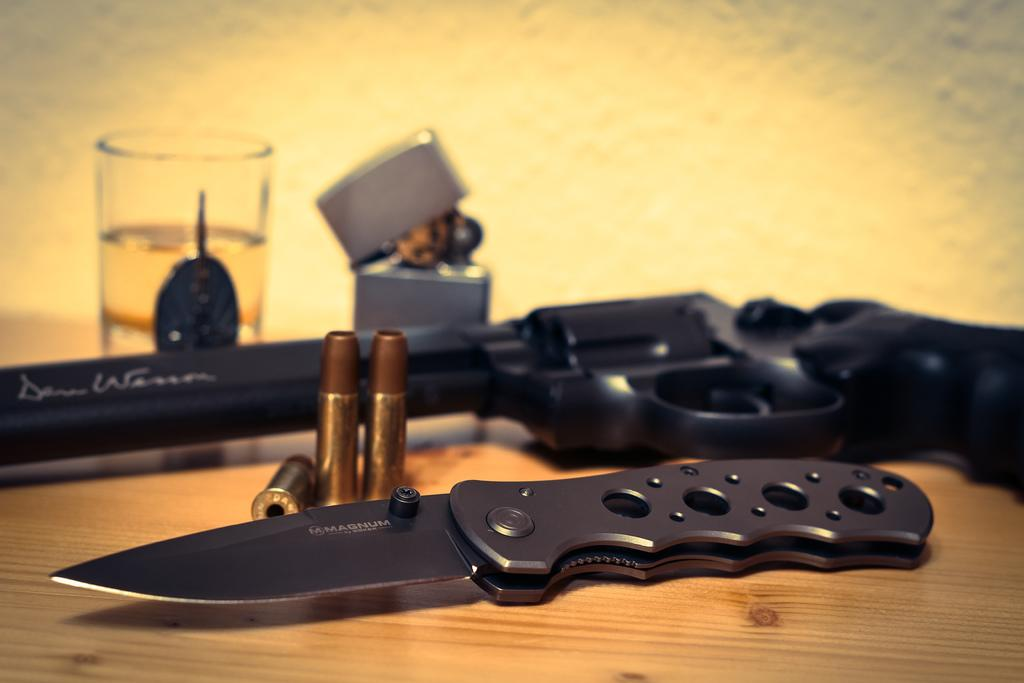What objects are on the wooden surface in the image? There is a knife, bullets, a gun, a glass, and a lighter on the wooden surface. What type of material is the surface made of? The surface is made of wood. What can be seen in the background of the image? There appears to be a wall in the background of the image. How does the yam contribute to the digestion process of the brothers in the image? There is no yam or brothers present in the image, so it is not possible to answer that question. 